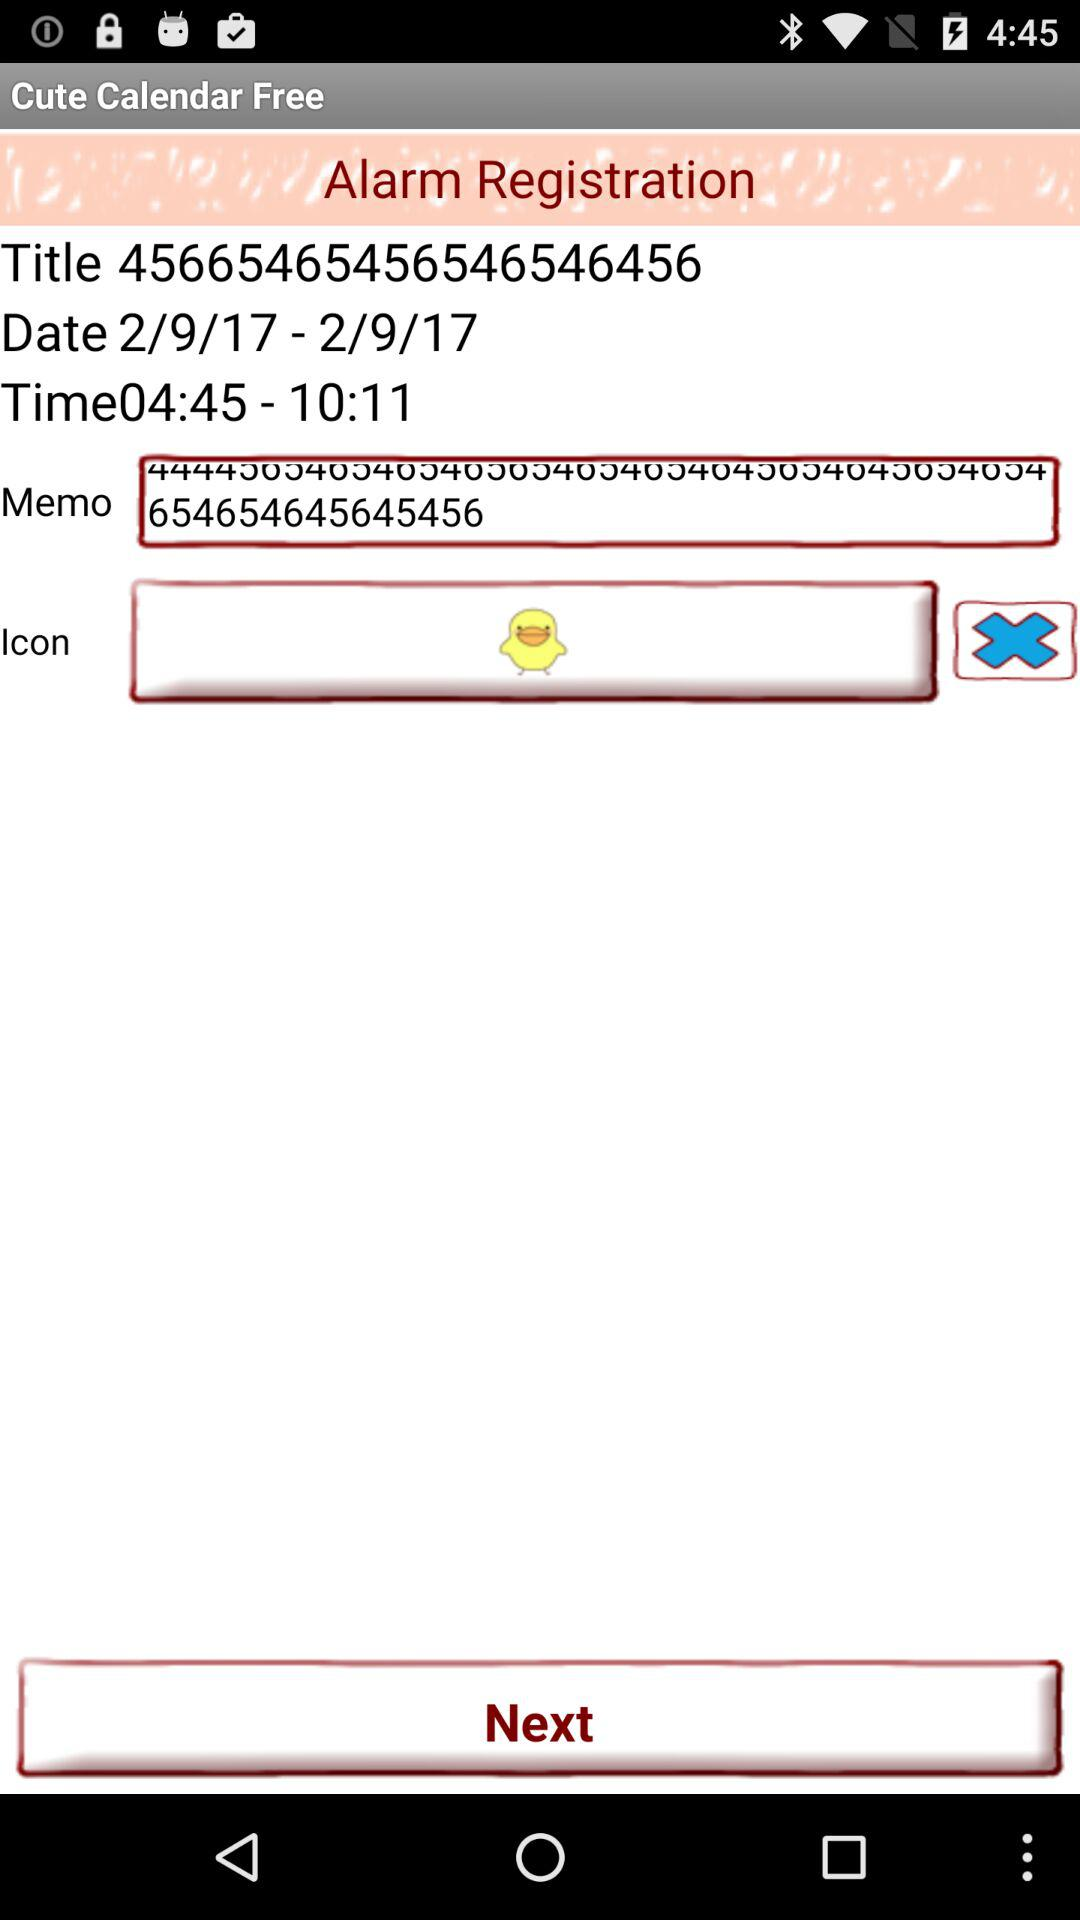What is the name of the application? The name of the application is "Cute Calendar Free". 